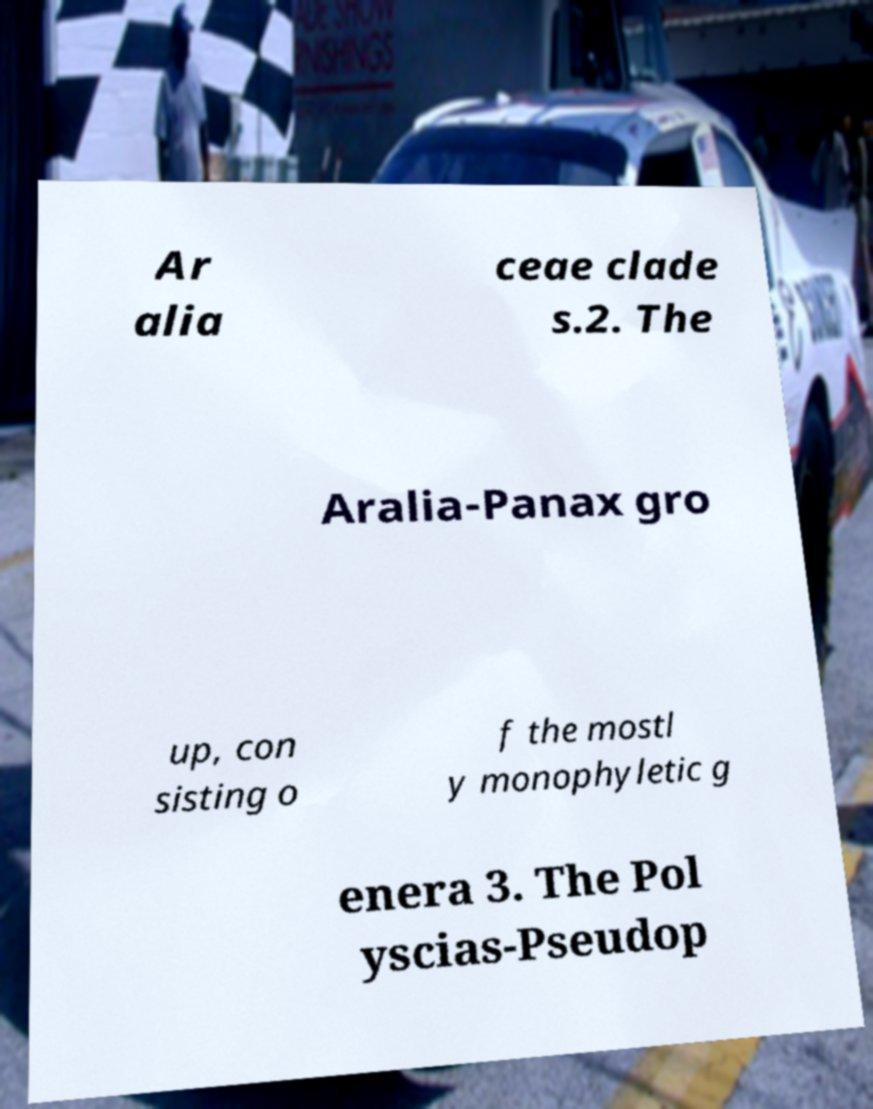Can you accurately transcribe the text from the provided image for me? Ar alia ceae clade s.2. The Aralia-Panax gro up, con sisting o f the mostl y monophyletic g enera 3. The Pol yscias-Pseudop 